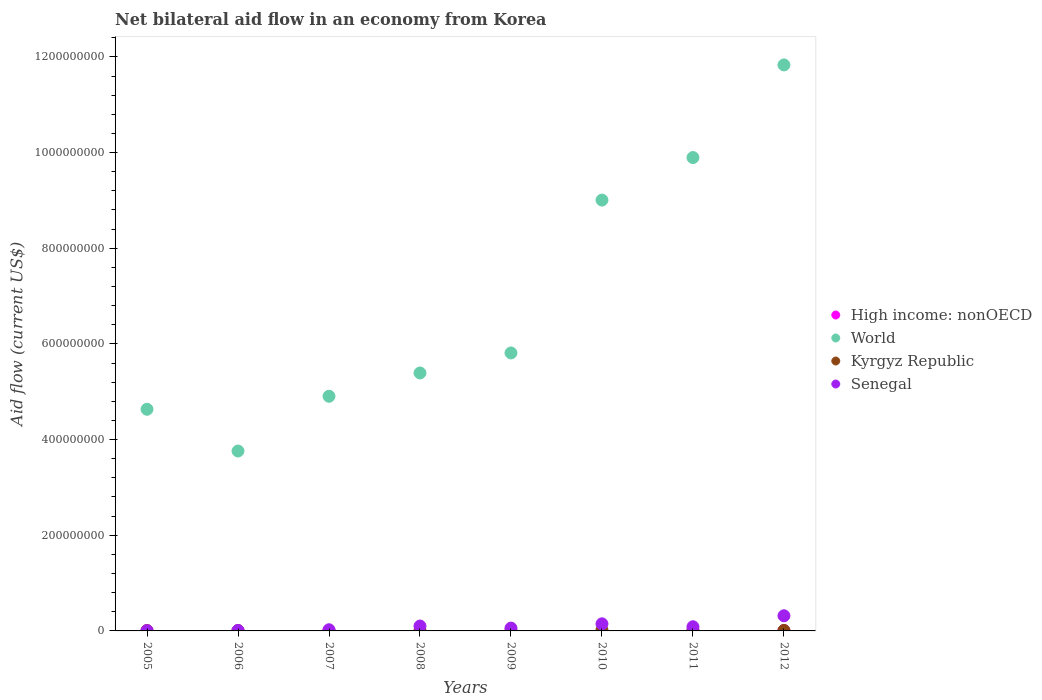Is the number of dotlines equal to the number of legend labels?
Keep it short and to the point. No. What is the net bilateral aid flow in Senegal in 2010?
Provide a short and direct response. 1.48e+07. Across all years, what is the maximum net bilateral aid flow in Senegal?
Give a very brief answer. 3.17e+07. In which year was the net bilateral aid flow in Senegal maximum?
Offer a terse response. 2012. What is the total net bilateral aid flow in Senegal in the graph?
Offer a terse response. 7.50e+07. What is the difference between the net bilateral aid flow in Senegal in 2005 and that in 2009?
Offer a terse response. -5.61e+06. What is the difference between the net bilateral aid flow in Kyrgyz Republic in 2010 and the net bilateral aid flow in High income: nonOECD in 2008?
Keep it short and to the point. 1.83e+06. What is the average net bilateral aid flow in High income: nonOECD per year?
Give a very brief answer. 4.24e+05. In the year 2012, what is the difference between the net bilateral aid flow in Senegal and net bilateral aid flow in Kyrgyz Republic?
Provide a succinct answer. 3.07e+07. What is the ratio of the net bilateral aid flow in Kyrgyz Republic in 2010 to that in 2011?
Offer a terse response. 1.51. Is the difference between the net bilateral aid flow in Senegal in 2010 and 2012 greater than the difference between the net bilateral aid flow in Kyrgyz Republic in 2010 and 2012?
Keep it short and to the point. No. What is the difference between the highest and the second highest net bilateral aid flow in World?
Make the answer very short. 1.94e+08. What is the difference between the highest and the lowest net bilateral aid flow in Senegal?
Make the answer very short. 3.14e+07. Is the sum of the net bilateral aid flow in Senegal in 2006 and 2011 greater than the maximum net bilateral aid flow in High income: nonOECD across all years?
Offer a terse response. Yes. Is the net bilateral aid flow in High income: nonOECD strictly greater than the net bilateral aid flow in Kyrgyz Republic over the years?
Make the answer very short. No. Is the net bilateral aid flow in World strictly less than the net bilateral aid flow in Senegal over the years?
Your response must be concise. No. What is the difference between two consecutive major ticks on the Y-axis?
Make the answer very short. 2.00e+08. Where does the legend appear in the graph?
Your answer should be compact. Center right. How are the legend labels stacked?
Provide a short and direct response. Vertical. What is the title of the graph?
Your answer should be compact. Net bilateral aid flow in an economy from Korea. What is the Aid flow (current US$) of High income: nonOECD in 2005?
Provide a short and direct response. 8.20e+05. What is the Aid flow (current US$) of World in 2005?
Provide a short and direct response. 4.63e+08. What is the Aid flow (current US$) of World in 2006?
Offer a very short reply. 3.76e+08. What is the Aid flow (current US$) of Senegal in 2006?
Give a very brief answer. 8.50e+05. What is the Aid flow (current US$) of High income: nonOECD in 2007?
Your answer should be very brief. 7.70e+05. What is the Aid flow (current US$) in World in 2007?
Provide a succinct answer. 4.91e+08. What is the Aid flow (current US$) of Kyrgyz Republic in 2007?
Your response must be concise. 1.50e+05. What is the Aid flow (current US$) of Senegal in 2007?
Your response must be concise. 2.43e+06. What is the Aid flow (current US$) in High income: nonOECD in 2008?
Give a very brief answer. 0. What is the Aid flow (current US$) in World in 2008?
Offer a terse response. 5.39e+08. What is the Aid flow (current US$) in Kyrgyz Republic in 2008?
Give a very brief answer. 7.10e+05. What is the Aid flow (current US$) in Senegal in 2008?
Give a very brief answer. 1.02e+07. What is the Aid flow (current US$) in World in 2009?
Provide a short and direct response. 5.81e+08. What is the Aid flow (current US$) of Kyrgyz Republic in 2009?
Offer a very short reply. 7.20e+05. What is the Aid flow (current US$) in Senegal in 2009?
Your response must be concise. 5.92e+06. What is the Aid flow (current US$) of World in 2010?
Offer a very short reply. 9.01e+08. What is the Aid flow (current US$) of Kyrgyz Republic in 2010?
Offer a terse response. 1.83e+06. What is the Aid flow (current US$) of Senegal in 2010?
Provide a short and direct response. 1.48e+07. What is the Aid flow (current US$) of High income: nonOECD in 2011?
Give a very brief answer. 6.00e+05. What is the Aid flow (current US$) of World in 2011?
Offer a very short reply. 9.90e+08. What is the Aid flow (current US$) of Kyrgyz Republic in 2011?
Offer a very short reply. 1.21e+06. What is the Aid flow (current US$) of Senegal in 2011?
Your answer should be very brief. 8.71e+06. What is the Aid flow (current US$) of High income: nonOECD in 2012?
Offer a very short reply. 7.00e+05. What is the Aid flow (current US$) of World in 2012?
Provide a succinct answer. 1.18e+09. What is the Aid flow (current US$) of Senegal in 2012?
Provide a succinct answer. 3.17e+07. Across all years, what is the maximum Aid flow (current US$) in High income: nonOECD?
Give a very brief answer. 8.20e+05. Across all years, what is the maximum Aid flow (current US$) in World?
Provide a succinct answer. 1.18e+09. Across all years, what is the maximum Aid flow (current US$) of Kyrgyz Republic?
Offer a terse response. 1.83e+06. Across all years, what is the maximum Aid flow (current US$) in Senegal?
Offer a very short reply. 3.17e+07. Across all years, what is the minimum Aid flow (current US$) of High income: nonOECD?
Provide a short and direct response. 0. Across all years, what is the minimum Aid flow (current US$) in World?
Your response must be concise. 3.76e+08. Across all years, what is the minimum Aid flow (current US$) of Kyrgyz Republic?
Your answer should be very brief. 1.50e+05. What is the total Aid flow (current US$) in High income: nonOECD in the graph?
Offer a very short reply. 3.39e+06. What is the total Aid flow (current US$) in World in the graph?
Offer a terse response. 5.52e+09. What is the total Aid flow (current US$) in Kyrgyz Republic in the graph?
Your answer should be compact. 6.65e+06. What is the total Aid flow (current US$) in Senegal in the graph?
Provide a short and direct response. 7.50e+07. What is the difference between the Aid flow (current US$) in World in 2005 and that in 2006?
Give a very brief answer. 8.73e+07. What is the difference between the Aid flow (current US$) of Senegal in 2005 and that in 2006?
Your answer should be compact. -5.40e+05. What is the difference between the Aid flow (current US$) of World in 2005 and that in 2007?
Offer a terse response. -2.72e+07. What is the difference between the Aid flow (current US$) in Senegal in 2005 and that in 2007?
Keep it short and to the point. -2.12e+06. What is the difference between the Aid flow (current US$) of World in 2005 and that in 2008?
Your response must be concise. -7.59e+07. What is the difference between the Aid flow (current US$) in Senegal in 2005 and that in 2008?
Give a very brief answer. -9.94e+06. What is the difference between the Aid flow (current US$) in World in 2005 and that in 2009?
Make the answer very short. -1.18e+08. What is the difference between the Aid flow (current US$) of Senegal in 2005 and that in 2009?
Your response must be concise. -5.61e+06. What is the difference between the Aid flow (current US$) of World in 2005 and that in 2010?
Make the answer very short. -4.37e+08. What is the difference between the Aid flow (current US$) in Kyrgyz Republic in 2005 and that in 2010?
Provide a short and direct response. -1.41e+06. What is the difference between the Aid flow (current US$) in Senegal in 2005 and that in 2010?
Keep it short and to the point. -1.45e+07. What is the difference between the Aid flow (current US$) of High income: nonOECD in 2005 and that in 2011?
Your answer should be compact. 2.20e+05. What is the difference between the Aid flow (current US$) of World in 2005 and that in 2011?
Provide a succinct answer. -5.26e+08. What is the difference between the Aid flow (current US$) of Kyrgyz Republic in 2005 and that in 2011?
Give a very brief answer. -7.90e+05. What is the difference between the Aid flow (current US$) of Senegal in 2005 and that in 2011?
Your answer should be compact. -8.40e+06. What is the difference between the Aid flow (current US$) in High income: nonOECD in 2005 and that in 2012?
Your answer should be compact. 1.20e+05. What is the difference between the Aid flow (current US$) in World in 2005 and that in 2012?
Provide a short and direct response. -7.20e+08. What is the difference between the Aid flow (current US$) in Kyrgyz Republic in 2005 and that in 2012?
Offer a very short reply. -5.80e+05. What is the difference between the Aid flow (current US$) in Senegal in 2005 and that in 2012?
Your answer should be very brief. -3.14e+07. What is the difference between the Aid flow (current US$) in World in 2006 and that in 2007?
Make the answer very short. -1.14e+08. What is the difference between the Aid flow (current US$) in Kyrgyz Republic in 2006 and that in 2007?
Your response must be concise. 4.60e+05. What is the difference between the Aid flow (current US$) in Senegal in 2006 and that in 2007?
Your answer should be compact. -1.58e+06. What is the difference between the Aid flow (current US$) of World in 2006 and that in 2008?
Your answer should be very brief. -1.63e+08. What is the difference between the Aid flow (current US$) of Senegal in 2006 and that in 2008?
Ensure brevity in your answer.  -9.40e+06. What is the difference between the Aid flow (current US$) of World in 2006 and that in 2009?
Your answer should be compact. -2.05e+08. What is the difference between the Aid flow (current US$) of Kyrgyz Republic in 2006 and that in 2009?
Offer a terse response. -1.10e+05. What is the difference between the Aid flow (current US$) in Senegal in 2006 and that in 2009?
Your answer should be compact. -5.07e+06. What is the difference between the Aid flow (current US$) in World in 2006 and that in 2010?
Your response must be concise. -5.25e+08. What is the difference between the Aid flow (current US$) in Kyrgyz Republic in 2006 and that in 2010?
Your response must be concise. -1.22e+06. What is the difference between the Aid flow (current US$) in Senegal in 2006 and that in 2010?
Provide a succinct answer. -1.40e+07. What is the difference between the Aid flow (current US$) of World in 2006 and that in 2011?
Offer a terse response. -6.13e+08. What is the difference between the Aid flow (current US$) in Kyrgyz Republic in 2006 and that in 2011?
Offer a terse response. -6.00e+05. What is the difference between the Aid flow (current US$) in Senegal in 2006 and that in 2011?
Offer a terse response. -7.86e+06. What is the difference between the Aid flow (current US$) in World in 2006 and that in 2012?
Your answer should be very brief. -8.07e+08. What is the difference between the Aid flow (current US$) in Kyrgyz Republic in 2006 and that in 2012?
Offer a very short reply. -3.90e+05. What is the difference between the Aid flow (current US$) of Senegal in 2006 and that in 2012?
Provide a short and direct response. -3.08e+07. What is the difference between the Aid flow (current US$) of World in 2007 and that in 2008?
Make the answer very short. -4.87e+07. What is the difference between the Aid flow (current US$) in Kyrgyz Republic in 2007 and that in 2008?
Ensure brevity in your answer.  -5.60e+05. What is the difference between the Aid flow (current US$) in Senegal in 2007 and that in 2008?
Your answer should be very brief. -7.82e+06. What is the difference between the Aid flow (current US$) of World in 2007 and that in 2009?
Your answer should be compact. -9.06e+07. What is the difference between the Aid flow (current US$) in Kyrgyz Republic in 2007 and that in 2009?
Offer a very short reply. -5.70e+05. What is the difference between the Aid flow (current US$) of Senegal in 2007 and that in 2009?
Your response must be concise. -3.49e+06. What is the difference between the Aid flow (current US$) of World in 2007 and that in 2010?
Offer a very short reply. -4.10e+08. What is the difference between the Aid flow (current US$) of Kyrgyz Republic in 2007 and that in 2010?
Offer a terse response. -1.68e+06. What is the difference between the Aid flow (current US$) of Senegal in 2007 and that in 2010?
Keep it short and to the point. -1.24e+07. What is the difference between the Aid flow (current US$) in High income: nonOECD in 2007 and that in 2011?
Make the answer very short. 1.70e+05. What is the difference between the Aid flow (current US$) of World in 2007 and that in 2011?
Keep it short and to the point. -4.99e+08. What is the difference between the Aid flow (current US$) of Kyrgyz Republic in 2007 and that in 2011?
Keep it short and to the point. -1.06e+06. What is the difference between the Aid flow (current US$) of Senegal in 2007 and that in 2011?
Make the answer very short. -6.28e+06. What is the difference between the Aid flow (current US$) of World in 2007 and that in 2012?
Offer a very short reply. -6.93e+08. What is the difference between the Aid flow (current US$) of Kyrgyz Republic in 2007 and that in 2012?
Your answer should be compact. -8.50e+05. What is the difference between the Aid flow (current US$) in Senegal in 2007 and that in 2012?
Offer a very short reply. -2.92e+07. What is the difference between the Aid flow (current US$) of World in 2008 and that in 2009?
Provide a succinct answer. -4.19e+07. What is the difference between the Aid flow (current US$) in Senegal in 2008 and that in 2009?
Keep it short and to the point. 4.33e+06. What is the difference between the Aid flow (current US$) in World in 2008 and that in 2010?
Provide a succinct answer. -3.61e+08. What is the difference between the Aid flow (current US$) in Kyrgyz Republic in 2008 and that in 2010?
Your answer should be very brief. -1.12e+06. What is the difference between the Aid flow (current US$) in Senegal in 2008 and that in 2010?
Provide a short and direct response. -4.60e+06. What is the difference between the Aid flow (current US$) of World in 2008 and that in 2011?
Your answer should be compact. -4.50e+08. What is the difference between the Aid flow (current US$) of Kyrgyz Republic in 2008 and that in 2011?
Your response must be concise. -5.00e+05. What is the difference between the Aid flow (current US$) in Senegal in 2008 and that in 2011?
Give a very brief answer. 1.54e+06. What is the difference between the Aid flow (current US$) in World in 2008 and that in 2012?
Your answer should be compact. -6.44e+08. What is the difference between the Aid flow (current US$) of Senegal in 2008 and that in 2012?
Your response must be concise. -2.14e+07. What is the difference between the Aid flow (current US$) in World in 2009 and that in 2010?
Give a very brief answer. -3.20e+08. What is the difference between the Aid flow (current US$) in Kyrgyz Republic in 2009 and that in 2010?
Offer a very short reply. -1.11e+06. What is the difference between the Aid flow (current US$) in Senegal in 2009 and that in 2010?
Offer a terse response. -8.93e+06. What is the difference between the Aid flow (current US$) in World in 2009 and that in 2011?
Keep it short and to the point. -4.08e+08. What is the difference between the Aid flow (current US$) in Kyrgyz Republic in 2009 and that in 2011?
Provide a succinct answer. -4.90e+05. What is the difference between the Aid flow (current US$) of Senegal in 2009 and that in 2011?
Offer a very short reply. -2.79e+06. What is the difference between the Aid flow (current US$) in World in 2009 and that in 2012?
Your response must be concise. -6.02e+08. What is the difference between the Aid flow (current US$) in Kyrgyz Republic in 2009 and that in 2012?
Your response must be concise. -2.80e+05. What is the difference between the Aid flow (current US$) in Senegal in 2009 and that in 2012?
Your answer should be very brief. -2.58e+07. What is the difference between the Aid flow (current US$) in World in 2010 and that in 2011?
Make the answer very short. -8.89e+07. What is the difference between the Aid flow (current US$) in Kyrgyz Republic in 2010 and that in 2011?
Keep it short and to the point. 6.20e+05. What is the difference between the Aid flow (current US$) of Senegal in 2010 and that in 2011?
Your answer should be compact. 6.14e+06. What is the difference between the Aid flow (current US$) in World in 2010 and that in 2012?
Keep it short and to the point. -2.83e+08. What is the difference between the Aid flow (current US$) of Kyrgyz Republic in 2010 and that in 2012?
Keep it short and to the point. 8.30e+05. What is the difference between the Aid flow (current US$) of Senegal in 2010 and that in 2012?
Ensure brevity in your answer.  -1.68e+07. What is the difference between the Aid flow (current US$) of World in 2011 and that in 2012?
Provide a succinct answer. -1.94e+08. What is the difference between the Aid flow (current US$) of Senegal in 2011 and that in 2012?
Your answer should be compact. -2.30e+07. What is the difference between the Aid flow (current US$) in High income: nonOECD in 2005 and the Aid flow (current US$) in World in 2006?
Provide a short and direct response. -3.75e+08. What is the difference between the Aid flow (current US$) of High income: nonOECD in 2005 and the Aid flow (current US$) of Senegal in 2006?
Your answer should be very brief. -3.00e+04. What is the difference between the Aid flow (current US$) of World in 2005 and the Aid flow (current US$) of Kyrgyz Republic in 2006?
Provide a succinct answer. 4.63e+08. What is the difference between the Aid flow (current US$) in World in 2005 and the Aid flow (current US$) in Senegal in 2006?
Offer a very short reply. 4.62e+08. What is the difference between the Aid flow (current US$) of Kyrgyz Republic in 2005 and the Aid flow (current US$) of Senegal in 2006?
Provide a succinct answer. -4.30e+05. What is the difference between the Aid flow (current US$) of High income: nonOECD in 2005 and the Aid flow (current US$) of World in 2007?
Keep it short and to the point. -4.90e+08. What is the difference between the Aid flow (current US$) in High income: nonOECD in 2005 and the Aid flow (current US$) in Kyrgyz Republic in 2007?
Provide a short and direct response. 6.70e+05. What is the difference between the Aid flow (current US$) of High income: nonOECD in 2005 and the Aid flow (current US$) of Senegal in 2007?
Keep it short and to the point. -1.61e+06. What is the difference between the Aid flow (current US$) of World in 2005 and the Aid flow (current US$) of Kyrgyz Republic in 2007?
Your response must be concise. 4.63e+08. What is the difference between the Aid flow (current US$) in World in 2005 and the Aid flow (current US$) in Senegal in 2007?
Make the answer very short. 4.61e+08. What is the difference between the Aid flow (current US$) of Kyrgyz Republic in 2005 and the Aid flow (current US$) of Senegal in 2007?
Your response must be concise. -2.01e+06. What is the difference between the Aid flow (current US$) of High income: nonOECD in 2005 and the Aid flow (current US$) of World in 2008?
Your answer should be very brief. -5.38e+08. What is the difference between the Aid flow (current US$) in High income: nonOECD in 2005 and the Aid flow (current US$) in Kyrgyz Republic in 2008?
Your answer should be compact. 1.10e+05. What is the difference between the Aid flow (current US$) of High income: nonOECD in 2005 and the Aid flow (current US$) of Senegal in 2008?
Your response must be concise. -9.43e+06. What is the difference between the Aid flow (current US$) of World in 2005 and the Aid flow (current US$) of Kyrgyz Republic in 2008?
Your answer should be compact. 4.63e+08. What is the difference between the Aid flow (current US$) in World in 2005 and the Aid flow (current US$) in Senegal in 2008?
Your answer should be compact. 4.53e+08. What is the difference between the Aid flow (current US$) of Kyrgyz Republic in 2005 and the Aid flow (current US$) of Senegal in 2008?
Your response must be concise. -9.83e+06. What is the difference between the Aid flow (current US$) in High income: nonOECD in 2005 and the Aid flow (current US$) in World in 2009?
Make the answer very short. -5.80e+08. What is the difference between the Aid flow (current US$) of High income: nonOECD in 2005 and the Aid flow (current US$) of Kyrgyz Republic in 2009?
Give a very brief answer. 1.00e+05. What is the difference between the Aid flow (current US$) in High income: nonOECD in 2005 and the Aid flow (current US$) in Senegal in 2009?
Keep it short and to the point. -5.10e+06. What is the difference between the Aid flow (current US$) in World in 2005 and the Aid flow (current US$) in Kyrgyz Republic in 2009?
Your answer should be very brief. 4.63e+08. What is the difference between the Aid flow (current US$) in World in 2005 and the Aid flow (current US$) in Senegal in 2009?
Your response must be concise. 4.57e+08. What is the difference between the Aid flow (current US$) in Kyrgyz Republic in 2005 and the Aid flow (current US$) in Senegal in 2009?
Your answer should be very brief. -5.50e+06. What is the difference between the Aid flow (current US$) of High income: nonOECD in 2005 and the Aid flow (current US$) of World in 2010?
Your response must be concise. -9.00e+08. What is the difference between the Aid flow (current US$) of High income: nonOECD in 2005 and the Aid flow (current US$) of Kyrgyz Republic in 2010?
Make the answer very short. -1.01e+06. What is the difference between the Aid flow (current US$) of High income: nonOECD in 2005 and the Aid flow (current US$) of Senegal in 2010?
Make the answer very short. -1.40e+07. What is the difference between the Aid flow (current US$) in World in 2005 and the Aid flow (current US$) in Kyrgyz Republic in 2010?
Your response must be concise. 4.62e+08. What is the difference between the Aid flow (current US$) in World in 2005 and the Aid flow (current US$) in Senegal in 2010?
Provide a short and direct response. 4.48e+08. What is the difference between the Aid flow (current US$) in Kyrgyz Republic in 2005 and the Aid flow (current US$) in Senegal in 2010?
Provide a succinct answer. -1.44e+07. What is the difference between the Aid flow (current US$) in High income: nonOECD in 2005 and the Aid flow (current US$) in World in 2011?
Your answer should be compact. -9.89e+08. What is the difference between the Aid flow (current US$) of High income: nonOECD in 2005 and the Aid flow (current US$) of Kyrgyz Republic in 2011?
Your answer should be very brief. -3.90e+05. What is the difference between the Aid flow (current US$) in High income: nonOECD in 2005 and the Aid flow (current US$) in Senegal in 2011?
Your answer should be very brief. -7.89e+06. What is the difference between the Aid flow (current US$) in World in 2005 and the Aid flow (current US$) in Kyrgyz Republic in 2011?
Offer a terse response. 4.62e+08. What is the difference between the Aid flow (current US$) of World in 2005 and the Aid flow (current US$) of Senegal in 2011?
Offer a terse response. 4.55e+08. What is the difference between the Aid flow (current US$) in Kyrgyz Republic in 2005 and the Aid flow (current US$) in Senegal in 2011?
Provide a short and direct response. -8.29e+06. What is the difference between the Aid flow (current US$) of High income: nonOECD in 2005 and the Aid flow (current US$) of World in 2012?
Your answer should be compact. -1.18e+09. What is the difference between the Aid flow (current US$) in High income: nonOECD in 2005 and the Aid flow (current US$) in Senegal in 2012?
Keep it short and to the point. -3.09e+07. What is the difference between the Aid flow (current US$) of World in 2005 and the Aid flow (current US$) of Kyrgyz Republic in 2012?
Offer a very short reply. 4.62e+08. What is the difference between the Aid flow (current US$) of World in 2005 and the Aid flow (current US$) of Senegal in 2012?
Your answer should be very brief. 4.32e+08. What is the difference between the Aid flow (current US$) of Kyrgyz Republic in 2005 and the Aid flow (current US$) of Senegal in 2012?
Keep it short and to the point. -3.13e+07. What is the difference between the Aid flow (current US$) of High income: nonOECD in 2006 and the Aid flow (current US$) of World in 2007?
Make the answer very short. -4.90e+08. What is the difference between the Aid flow (current US$) in High income: nonOECD in 2006 and the Aid flow (current US$) in Senegal in 2007?
Make the answer very short. -1.93e+06. What is the difference between the Aid flow (current US$) of World in 2006 and the Aid flow (current US$) of Kyrgyz Republic in 2007?
Make the answer very short. 3.76e+08. What is the difference between the Aid flow (current US$) of World in 2006 and the Aid flow (current US$) of Senegal in 2007?
Ensure brevity in your answer.  3.74e+08. What is the difference between the Aid flow (current US$) in Kyrgyz Republic in 2006 and the Aid flow (current US$) in Senegal in 2007?
Offer a very short reply. -1.82e+06. What is the difference between the Aid flow (current US$) in High income: nonOECD in 2006 and the Aid flow (current US$) in World in 2008?
Give a very brief answer. -5.39e+08. What is the difference between the Aid flow (current US$) of High income: nonOECD in 2006 and the Aid flow (current US$) of Kyrgyz Republic in 2008?
Make the answer very short. -2.10e+05. What is the difference between the Aid flow (current US$) in High income: nonOECD in 2006 and the Aid flow (current US$) in Senegal in 2008?
Give a very brief answer. -9.75e+06. What is the difference between the Aid flow (current US$) of World in 2006 and the Aid flow (current US$) of Kyrgyz Republic in 2008?
Offer a very short reply. 3.75e+08. What is the difference between the Aid flow (current US$) of World in 2006 and the Aid flow (current US$) of Senegal in 2008?
Provide a succinct answer. 3.66e+08. What is the difference between the Aid flow (current US$) of Kyrgyz Republic in 2006 and the Aid flow (current US$) of Senegal in 2008?
Make the answer very short. -9.64e+06. What is the difference between the Aid flow (current US$) of High income: nonOECD in 2006 and the Aid flow (current US$) of World in 2009?
Provide a succinct answer. -5.81e+08. What is the difference between the Aid flow (current US$) in High income: nonOECD in 2006 and the Aid flow (current US$) in Kyrgyz Republic in 2009?
Offer a very short reply. -2.20e+05. What is the difference between the Aid flow (current US$) of High income: nonOECD in 2006 and the Aid flow (current US$) of Senegal in 2009?
Your response must be concise. -5.42e+06. What is the difference between the Aid flow (current US$) in World in 2006 and the Aid flow (current US$) in Kyrgyz Republic in 2009?
Provide a short and direct response. 3.75e+08. What is the difference between the Aid flow (current US$) of World in 2006 and the Aid flow (current US$) of Senegal in 2009?
Make the answer very short. 3.70e+08. What is the difference between the Aid flow (current US$) in Kyrgyz Republic in 2006 and the Aid flow (current US$) in Senegal in 2009?
Ensure brevity in your answer.  -5.31e+06. What is the difference between the Aid flow (current US$) in High income: nonOECD in 2006 and the Aid flow (current US$) in World in 2010?
Make the answer very short. -9.00e+08. What is the difference between the Aid flow (current US$) in High income: nonOECD in 2006 and the Aid flow (current US$) in Kyrgyz Republic in 2010?
Your response must be concise. -1.33e+06. What is the difference between the Aid flow (current US$) in High income: nonOECD in 2006 and the Aid flow (current US$) in Senegal in 2010?
Make the answer very short. -1.44e+07. What is the difference between the Aid flow (current US$) of World in 2006 and the Aid flow (current US$) of Kyrgyz Republic in 2010?
Your answer should be compact. 3.74e+08. What is the difference between the Aid flow (current US$) in World in 2006 and the Aid flow (current US$) in Senegal in 2010?
Your answer should be compact. 3.61e+08. What is the difference between the Aid flow (current US$) of Kyrgyz Republic in 2006 and the Aid flow (current US$) of Senegal in 2010?
Ensure brevity in your answer.  -1.42e+07. What is the difference between the Aid flow (current US$) in High income: nonOECD in 2006 and the Aid flow (current US$) in World in 2011?
Your response must be concise. -9.89e+08. What is the difference between the Aid flow (current US$) of High income: nonOECD in 2006 and the Aid flow (current US$) of Kyrgyz Republic in 2011?
Your response must be concise. -7.10e+05. What is the difference between the Aid flow (current US$) in High income: nonOECD in 2006 and the Aid flow (current US$) in Senegal in 2011?
Keep it short and to the point. -8.21e+06. What is the difference between the Aid flow (current US$) in World in 2006 and the Aid flow (current US$) in Kyrgyz Republic in 2011?
Make the answer very short. 3.75e+08. What is the difference between the Aid flow (current US$) in World in 2006 and the Aid flow (current US$) in Senegal in 2011?
Keep it short and to the point. 3.67e+08. What is the difference between the Aid flow (current US$) of Kyrgyz Republic in 2006 and the Aid flow (current US$) of Senegal in 2011?
Make the answer very short. -8.10e+06. What is the difference between the Aid flow (current US$) in High income: nonOECD in 2006 and the Aid flow (current US$) in World in 2012?
Ensure brevity in your answer.  -1.18e+09. What is the difference between the Aid flow (current US$) in High income: nonOECD in 2006 and the Aid flow (current US$) in Kyrgyz Republic in 2012?
Keep it short and to the point. -5.00e+05. What is the difference between the Aid flow (current US$) in High income: nonOECD in 2006 and the Aid flow (current US$) in Senegal in 2012?
Offer a terse response. -3.12e+07. What is the difference between the Aid flow (current US$) of World in 2006 and the Aid flow (current US$) of Kyrgyz Republic in 2012?
Give a very brief answer. 3.75e+08. What is the difference between the Aid flow (current US$) of World in 2006 and the Aid flow (current US$) of Senegal in 2012?
Provide a succinct answer. 3.44e+08. What is the difference between the Aid flow (current US$) in Kyrgyz Republic in 2006 and the Aid flow (current US$) in Senegal in 2012?
Provide a short and direct response. -3.11e+07. What is the difference between the Aid flow (current US$) of High income: nonOECD in 2007 and the Aid flow (current US$) of World in 2008?
Your response must be concise. -5.38e+08. What is the difference between the Aid flow (current US$) in High income: nonOECD in 2007 and the Aid flow (current US$) in Kyrgyz Republic in 2008?
Provide a succinct answer. 6.00e+04. What is the difference between the Aid flow (current US$) in High income: nonOECD in 2007 and the Aid flow (current US$) in Senegal in 2008?
Ensure brevity in your answer.  -9.48e+06. What is the difference between the Aid flow (current US$) in World in 2007 and the Aid flow (current US$) in Kyrgyz Republic in 2008?
Your answer should be very brief. 4.90e+08. What is the difference between the Aid flow (current US$) of World in 2007 and the Aid flow (current US$) of Senegal in 2008?
Offer a terse response. 4.80e+08. What is the difference between the Aid flow (current US$) of Kyrgyz Republic in 2007 and the Aid flow (current US$) of Senegal in 2008?
Offer a terse response. -1.01e+07. What is the difference between the Aid flow (current US$) of High income: nonOECD in 2007 and the Aid flow (current US$) of World in 2009?
Your answer should be compact. -5.80e+08. What is the difference between the Aid flow (current US$) of High income: nonOECD in 2007 and the Aid flow (current US$) of Kyrgyz Republic in 2009?
Make the answer very short. 5.00e+04. What is the difference between the Aid flow (current US$) of High income: nonOECD in 2007 and the Aid flow (current US$) of Senegal in 2009?
Offer a very short reply. -5.15e+06. What is the difference between the Aid flow (current US$) in World in 2007 and the Aid flow (current US$) in Kyrgyz Republic in 2009?
Keep it short and to the point. 4.90e+08. What is the difference between the Aid flow (current US$) of World in 2007 and the Aid flow (current US$) of Senegal in 2009?
Ensure brevity in your answer.  4.85e+08. What is the difference between the Aid flow (current US$) of Kyrgyz Republic in 2007 and the Aid flow (current US$) of Senegal in 2009?
Your response must be concise. -5.77e+06. What is the difference between the Aid flow (current US$) of High income: nonOECD in 2007 and the Aid flow (current US$) of World in 2010?
Your answer should be compact. -9.00e+08. What is the difference between the Aid flow (current US$) in High income: nonOECD in 2007 and the Aid flow (current US$) in Kyrgyz Republic in 2010?
Provide a succinct answer. -1.06e+06. What is the difference between the Aid flow (current US$) in High income: nonOECD in 2007 and the Aid flow (current US$) in Senegal in 2010?
Keep it short and to the point. -1.41e+07. What is the difference between the Aid flow (current US$) in World in 2007 and the Aid flow (current US$) in Kyrgyz Republic in 2010?
Your response must be concise. 4.89e+08. What is the difference between the Aid flow (current US$) of World in 2007 and the Aid flow (current US$) of Senegal in 2010?
Provide a succinct answer. 4.76e+08. What is the difference between the Aid flow (current US$) of Kyrgyz Republic in 2007 and the Aid flow (current US$) of Senegal in 2010?
Offer a terse response. -1.47e+07. What is the difference between the Aid flow (current US$) in High income: nonOECD in 2007 and the Aid flow (current US$) in World in 2011?
Your response must be concise. -9.89e+08. What is the difference between the Aid flow (current US$) in High income: nonOECD in 2007 and the Aid flow (current US$) in Kyrgyz Republic in 2011?
Ensure brevity in your answer.  -4.40e+05. What is the difference between the Aid flow (current US$) in High income: nonOECD in 2007 and the Aid flow (current US$) in Senegal in 2011?
Your answer should be very brief. -7.94e+06. What is the difference between the Aid flow (current US$) in World in 2007 and the Aid flow (current US$) in Kyrgyz Republic in 2011?
Keep it short and to the point. 4.89e+08. What is the difference between the Aid flow (current US$) of World in 2007 and the Aid flow (current US$) of Senegal in 2011?
Your answer should be compact. 4.82e+08. What is the difference between the Aid flow (current US$) in Kyrgyz Republic in 2007 and the Aid flow (current US$) in Senegal in 2011?
Give a very brief answer. -8.56e+06. What is the difference between the Aid flow (current US$) of High income: nonOECD in 2007 and the Aid flow (current US$) of World in 2012?
Offer a very short reply. -1.18e+09. What is the difference between the Aid flow (current US$) of High income: nonOECD in 2007 and the Aid flow (current US$) of Kyrgyz Republic in 2012?
Your response must be concise. -2.30e+05. What is the difference between the Aid flow (current US$) in High income: nonOECD in 2007 and the Aid flow (current US$) in Senegal in 2012?
Provide a short and direct response. -3.09e+07. What is the difference between the Aid flow (current US$) of World in 2007 and the Aid flow (current US$) of Kyrgyz Republic in 2012?
Make the answer very short. 4.90e+08. What is the difference between the Aid flow (current US$) in World in 2007 and the Aid flow (current US$) in Senegal in 2012?
Your response must be concise. 4.59e+08. What is the difference between the Aid flow (current US$) of Kyrgyz Republic in 2007 and the Aid flow (current US$) of Senegal in 2012?
Offer a terse response. -3.15e+07. What is the difference between the Aid flow (current US$) in World in 2008 and the Aid flow (current US$) in Kyrgyz Republic in 2009?
Your answer should be compact. 5.38e+08. What is the difference between the Aid flow (current US$) in World in 2008 and the Aid flow (current US$) in Senegal in 2009?
Keep it short and to the point. 5.33e+08. What is the difference between the Aid flow (current US$) of Kyrgyz Republic in 2008 and the Aid flow (current US$) of Senegal in 2009?
Keep it short and to the point. -5.21e+06. What is the difference between the Aid flow (current US$) of World in 2008 and the Aid flow (current US$) of Kyrgyz Republic in 2010?
Offer a very short reply. 5.37e+08. What is the difference between the Aid flow (current US$) of World in 2008 and the Aid flow (current US$) of Senegal in 2010?
Provide a succinct answer. 5.24e+08. What is the difference between the Aid flow (current US$) in Kyrgyz Republic in 2008 and the Aid flow (current US$) in Senegal in 2010?
Provide a short and direct response. -1.41e+07. What is the difference between the Aid flow (current US$) in World in 2008 and the Aid flow (current US$) in Kyrgyz Republic in 2011?
Your answer should be very brief. 5.38e+08. What is the difference between the Aid flow (current US$) of World in 2008 and the Aid flow (current US$) of Senegal in 2011?
Your answer should be very brief. 5.30e+08. What is the difference between the Aid flow (current US$) of Kyrgyz Republic in 2008 and the Aid flow (current US$) of Senegal in 2011?
Give a very brief answer. -8.00e+06. What is the difference between the Aid flow (current US$) in World in 2008 and the Aid flow (current US$) in Kyrgyz Republic in 2012?
Keep it short and to the point. 5.38e+08. What is the difference between the Aid flow (current US$) of World in 2008 and the Aid flow (current US$) of Senegal in 2012?
Offer a terse response. 5.08e+08. What is the difference between the Aid flow (current US$) in Kyrgyz Republic in 2008 and the Aid flow (current US$) in Senegal in 2012?
Ensure brevity in your answer.  -3.10e+07. What is the difference between the Aid flow (current US$) of World in 2009 and the Aid flow (current US$) of Kyrgyz Republic in 2010?
Your answer should be very brief. 5.79e+08. What is the difference between the Aid flow (current US$) in World in 2009 and the Aid flow (current US$) in Senegal in 2010?
Make the answer very short. 5.66e+08. What is the difference between the Aid flow (current US$) in Kyrgyz Republic in 2009 and the Aid flow (current US$) in Senegal in 2010?
Your answer should be compact. -1.41e+07. What is the difference between the Aid flow (current US$) of World in 2009 and the Aid flow (current US$) of Kyrgyz Republic in 2011?
Your response must be concise. 5.80e+08. What is the difference between the Aid flow (current US$) in World in 2009 and the Aid flow (current US$) in Senegal in 2011?
Your response must be concise. 5.72e+08. What is the difference between the Aid flow (current US$) of Kyrgyz Republic in 2009 and the Aid flow (current US$) of Senegal in 2011?
Make the answer very short. -7.99e+06. What is the difference between the Aid flow (current US$) of World in 2009 and the Aid flow (current US$) of Kyrgyz Republic in 2012?
Give a very brief answer. 5.80e+08. What is the difference between the Aid flow (current US$) of World in 2009 and the Aid flow (current US$) of Senegal in 2012?
Ensure brevity in your answer.  5.49e+08. What is the difference between the Aid flow (current US$) in Kyrgyz Republic in 2009 and the Aid flow (current US$) in Senegal in 2012?
Provide a short and direct response. -3.10e+07. What is the difference between the Aid flow (current US$) of World in 2010 and the Aid flow (current US$) of Kyrgyz Republic in 2011?
Your answer should be compact. 8.99e+08. What is the difference between the Aid flow (current US$) in World in 2010 and the Aid flow (current US$) in Senegal in 2011?
Provide a short and direct response. 8.92e+08. What is the difference between the Aid flow (current US$) of Kyrgyz Republic in 2010 and the Aid flow (current US$) of Senegal in 2011?
Ensure brevity in your answer.  -6.88e+06. What is the difference between the Aid flow (current US$) in World in 2010 and the Aid flow (current US$) in Kyrgyz Republic in 2012?
Keep it short and to the point. 9.00e+08. What is the difference between the Aid flow (current US$) of World in 2010 and the Aid flow (current US$) of Senegal in 2012?
Keep it short and to the point. 8.69e+08. What is the difference between the Aid flow (current US$) in Kyrgyz Republic in 2010 and the Aid flow (current US$) in Senegal in 2012?
Give a very brief answer. -2.98e+07. What is the difference between the Aid flow (current US$) in High income: nonOECD in 2011 and the Aid flow (current US$) in World in 2012?
Give a very brief answer. -1.18e+09. What is the difference between the Aid flow (current US$) in High income: nonOECD in 2011 and the Aid flow (current US$) in Kyrgyz Republic in 2012?
Provide a short and direct response. -4.00e+05. What is the difference between the Aid flow (current US$) of High income: nonOECD in 2011 and the Aid flow (current US$) of Senegal in 2012?
Your answer should be compact. -3.11e+07. What is the difference between the Aid flow (current US$) in World in 2011 and the Aid flow (current US$) in Kyrgyz Republic in 2012?
Your answer should be compact. 9.89e+08. What is the difference between the Aid flow (current US$) of World in 2011 and the Aid flow (current US$) of Senegal in 2012?
Provide a short and direct response. 9.58e+08. What is the difference between the Aid flow (current US$) of Kyrgyz Republic in 2011 and the Aid flow (current US$) of Senegal in 2012?
Provide a short and direct response. -3.05e+07. What is the average Aid flow (current US$) in High income: nonOECD per year?
Ensure brevity in your answer.  4.24e+05. What is the average Aid flow (current US$) of World per year?
Your response must be concise. 6.90e+08. What is the average Aid flow (current US$) in Kyrgyz Republic per year?
Keep it short and to the point. 8.31e+05. What is the average Aid flow (current US$) of Senegal per year?
Your response must be concise. 9.38e+06. In the year 2005, what is the difference between the Aid flow (current US$) of High income: nonOECD and Aid flow (current US$) of World?
Your answer should be very brief. -4.63e+08. In the year 2005, what is the difference between the Aid flow (current US$) in High income: nonOECD and Aid flow (current US$) in Senegal?
Ensure brevity in your answer.  5.10e+05. In the year 2005, what is the difference between the Aid flow (current US$) of World and Aid flow (current US$) of Kyrgyz Republic?
Your response must be concise. 4.63e+08. In the year 2005, what is the difference between the Aid flow (current US$) of World and Aid flow (current US$) of Senegal?
Your response must be concise. 4.63e+08. In the year 2006, what is the difference between the Aid flow (current US$) in High income: nonOECD and Aid flow (current US$) in World?
Your answer should be very brief. -3.76e+08. In the year 2006, what is the difference between the Aid flow (current US$) in High income: nonOECD and Aid flow (current US$) in Kyrgyz Republic?
Give a very brief answer. -1.10e+05. In the year 2006, what is the difference between the Aid flow (current US$) of High income: nonOECD and Aid flow (current US$) of Senegal?
Your answer should be very brief. -3.50e+05. In the year 2006, what is the difference between the Aid flow (current US$) in World and Aid flow (current US$) in Kyrgyz Republic?
Your answer should be very brief. 3.75e+08. In the year 2006, what is the difference between the Aid flow (current US$) of World and Aid flow (current US$) of Senegal?
Offer a very short reply. 3.75e+08. In the year 2007, what is the difference between the Aid flow (current US$) in High income: nonOECD and Aid flow (current US$) in World?
Offer a terse response. -4.90e+08. In the year 2007, what is the difference between the Aid flow (current US$) of High income: nonOECD and Aid flow (current US$) of Kyrgyz Republic?
Your answer should be very brief. 6.20e+05. In the year 2007, what is the difference between the Aid flow (current US$) of High income: nonOECD and Aid flow (current US$) of Senegal?
Your answer should be very brief. -1.66e+06. In the year 2007, what is the difference between the Aid flow (current US$) in World and Aid flow (current US$) in Kyrgyz Republic?
Give a very brief answer. 4.90e+08. In the year 2007, what is the difference between the Aid flow (current US$) of World and Aid flow (current US$) of Senegal?
Your answer should be compact. 4.88e+08. In the year 2007, what is the difference between the Aid flow (current US$) in Kyrgyz Republic and Aid flow (current US$) in Senegal?
Your response must be concise. -2.28e+06. In the year 2008, what is the difference between the Aid flow (current US$) in World and Aid flow (current US$) in Kyrgyz Republic?
Provide a succinct answer. 5.38e+08. In the year 2008, what is the difference between the Aid flow (current US$) of World and Aid flow (current US$) of Senegal?
Give a very brief answer. 5.29e+08. In the year 2008, what is the difference between the Aid flow (current US$) in Kyrgyz Republic and Aid flow (current US$) in Senegal?
Make the answer very short. -9.54e+06. In the year 2009, what is the difference between the Aid flow (current US$) in World and Aid flow (current US$) in Kyrgyz Republic?
Offer a terse response. 5.80e+08. In the year 2009, what is the difference between the Aid flow (current US$) of World and Aid flow (current US$) of Senegal?
Your answer should be very brief. 5.75e+08. In the year 2009, what is the difference between the Aid flow (current US$) of Kyrgyz Republic and Aid flow (current US$) of Senegal?
Provide a succinct answer. -5.20e+06. In the year 2010, what is the difference between the Aid flow (current US$) of World and Aid flow (current US$) of Kyrgyz Republic?
Offer a terse response. 8.99e+08. In the year 2010, what is the difference between the Aid flow (current US$) in World and Aid flow (current US$) in Senegal?
Keep it short and to the point. 8.86e+08. In the year 2010, what is the difference between the Aid flow (current US$) of Kyrgyz Republic and Aid flow (current US$) of Senegal?
Make the answer very short. -1.30e+07. In the year 2011, what is the difference between the Aid flow (current US$) in High income: nonOECD and Aid flow (current US$) in World?
Your answer should be very brief. -9.89e+08. In the year 2011, what is the difference between the Aid flow (current US$) in High income: nonOECD and Aid flow (current US$) in Kyrgyz Republic?
Make the answer very short. -6.10e+05. In the year 2011, what is the difference between the Aid flow (current US$) of High income: nonOECD and Aid flow (current US$) of Senegal?
Make the answer very short. -8.11e+06. In the year 2011, what is the difference between the Aid flow (current US$) of World and Aid flow (current US$) of Kyrgyz Republic?
Offer a very short reply. 9.88e+08. In the year 2011, what is the difference between the Aid flow (current US$) of World and Aid flow (current US$) of Senegal?
Your answer should be compact. 9.81e+08. In the year 2011, what is the difference between the Aid flow (current US$) of Kyrgyz Republic and Aid flow (current US$) of Senegal?
Your answer should be compact. -7.50e+06. In the year 2012, what is the difference between the Aid flow (current US$) of High income: nonOECD and Aid flow (current US$) of World?
Your response must be concise. -1.18e+09. In the year 2012, what is the difference between the Aid flow (current US$) of High income: nonOECD and Aid flow (current US$) of Kyrgyz Republic?
Your response must be concise. -3.00e+05. In the year 2012, what is the difference between the Aid flow (current US$) in High income: nonOECD and Aid flow (current US$) in Senegal?
Provide a short and direct response. -3.10e+07. In the year 2012, what is the difference between the Aid flow (current US$) in World and Aid flow (current US$) in Kyrgyz Republic?
Provide a short and direct response. 1.18e+09. In the year 2012, what is the difference between the Aid flow (current US$) in World and Aid flow (current US$) in Senegal?
Give a very brief answer. 1.15e+09. In the year 2012, what is the difference between the Aid flow (current US$) in Kyrgyz Republic and Aid flow (current US$) in Senegal?
Offer a terse response. -3.07e+07. What is the ratio of the Aid flow (current US$) in High income: nonOECD in 2005 to that in 2006?
Your answer should be compact. 1.64. What is the ratio of the Aid flow (current US$) in World in 2005 to that in 2006?
Offer a terse response. 1.23. What is the ratio of the Aid flow (current US$) in Kyrgyz Republic in 2005 to that in 2006?
Give a very brief answer. 0.69. What is the ratio of the Aid flow (current US$) in Senegal in 2005 to that in 2006?
Your response must be concise. 0.36. What is the ratio of the Aid flow (current US$) in High income: nonOECD in 2005 to that in 2007?
Offer a terse response. 1.06. What is the ratio of the Aid flow (current US$) in World in 2005 to that in 2007?
Provide a succinct answer. 0.94. What is the ratio of the Aid flow (current US$) in Senegal in 2005 to that in 2007?
Provide a short and direct response. 0.13. What is the ratio of the Aid flow (current US$) in World in 2005 to that in 2008?
Make the answer very short. 0.86. What is the ratio of the Aid flow (current US$) in Kyrgyz Republic in 2005 to that in 2008?
Your answer should be compact. 0.59. What is the ratio of the Aid flow (current US$) of Senegal in 2005 to that in 2008?
Offer a very short reply. 0.03. What is the ratio of the Aid flow (current US$) in World in 2005 to that in 2009?
Your answer should be compact. 0.8. What is the ratio of the Aid flow (current US$) in Kyrgyz Republic in 2005 to that in 2009?
Provide a short and direct response. 0.58. What is the ratio of the Aid flow (current US$) of Senegal in 2005 to that in 2009?
Your response must be concise. 0.05. What is the ratio of the Aid flow (current US$) in World in 2005 to that in 2010?
Ensure brevity in your answer.  0.51. What is the ratio of the Aid flow (current US$) in Kyrgyz Republic in 2005 to that in 2010?
Give a very brief answer. 0.23. What is the ratio of the Aid flow (current US$) of Senegal in 2005 to that in 2010?
Give a very brief answer. 0.02. What is the ratio of the Aid flow (current US$) in High income: nonOECD in 2005 to that in 2011?
Keep it short and to the point. 1.37. What is the ratio of the Aid flow (current US$) in World in 2005 to that in 2011?
Your response must be concise. 0.47. What is the ratio of the Aid flow (current US$) in Kyrgyz Republic in 2005 to that in 2011?
Offer a very short reply. 0.35. What is the ratio of the Aid flow (current US$) of Senegal in 2005 to that in 2011?
Ensure brevity in your answer.  0.04. What is the ratio of the Aid flow (current US$) in High income: nonOECD in 2005 to that in 2012?
Make the answer very short. 1.17. What is the ratio of the Aid flow (current US$) of World in 2005 to that in 2012?
Provide a short and direct response. 0.39. What is the ratio of the Aid flow (current US$) in Kyrgyz Republic in 2005 to that in 2012?
Give a very brief answer. 0.42. What is the ratio of the Aid flow (current US$) in Senegal in 2005 to that in 2012?
Make the answer very short. 0.01. What is the ratio of the Aid flow (current US$) of High income: nonOECD in 2006 to that in 2007?
Make the answer very short. 0.65. What is the ratio of the Aid flow (current US$) in World in 2006 to that in 2007?
Offer a terse response. 0.77. What is the ratio of the Aid flow (current US$) in Kyrgyz Republic in 2006 to that in 2007?
Your answer should be very brief. 4.07. What is the ratio of the Aid flow (current US$) in Senegal in 2006 to that in 2007?
Offer a very short reply. 0.35. What is the ratio of the Aid flow (current US$) of World in 2006 to that in 2008?
Make the answer very short. 0.7. What is the ratio of the Aid flow (current US$) in Kyrgyz Republic in 2006 to that in 2008?
Your answer should be compact. 0.86. What is the ratio of the Aid flow (current US$) of Senegal in 2006 to that in 2008?
Offer a very short reply. 0.08. What is the ratio of the Aid flow (current US$) of World in 2006 to that in 2009?
Ensure brevity in your answer.  0.65. What is the ratio of the Aid flow (current US$) of Kyrgyz Republic in 2006 to that in 2009?
Offer a very short reply. 0.85. What is the ratio of the Aid flow (current US$) of Senegal in 2006 to that in 2009?
Keep it short and to the point. 0.14. What is the ratio of the Aid flow (current US$) of World in 2006 to that in 2010?
Ensure brevity in your answer.  0.42. What is the ratio of the Aid flow (current US$) of Kyrgyz Republic in 2006 to that in 2010?
Provide a succinct answer. 0.33. What is the ratio of the Aid flow (current US$) in Senegal in 2006 to that in 2010?
Keep it short and to the point. 0.06. What is the ratio of the Aid flow (current US$) of World in 2006 to that in 2011?
Offer a very short reply. 0.38. What is the ratio of the Aid flow (current US$) in Kyrgyz Republic in 2006 to that in 2011?
Offer a very short reply. 0.5. What is the ratio of the Aid flow (current US$) of Senegal in 2006 to that in 2011?
Your answer should be compact. 0.1. What is the ratio of the Aid flow (current US$) of High income: nonOECD in 2006 to that in 2012?
Your answer should be very brief. 0.71. What is the ratio of the Aid flow (current US$) in World in 2006 to that in 2012?
Offer a terse response. 0.32. What is the ratio of the Aid flow (current US$) of Kyrgyz Republic in 2006 to that in 2012?
Give a very brief answer. 0.61. What is the ratio of the Aid flow (current US$) in Senegal in 2006 to that in 2012?
Keep it short and to the point. 0.03. What is the ratio of the Aid flow (current US$) of World in 2007 to that in 2008?
Your answer should be very brief. 0.91. What is the ratio of the Aid flow (current US$) of Kyrgyz Republic in 2007 to that in 2008?
Make the answer very short. 0.21. What is the ratio of the Aid flow (current US$) of Senegal in 2007 to that in 2008?
Make the answer very short. 0.24. What is the ratio of the Aid flow (current US$) of World in 2007 to that in 2009?
Ensure brevity in your answer.  0.84. What is the ratio of the Aid flow (current US$) in Kyrgyz Republic in 2007 to that in 2009?
Offer a terse response. 0.21. What is the ratio of the Aid flow (current US$) of Senegal in 2007 to that in 2009?
Keep it short and to the point. 0.41. What is the ratio of the Aid flow (current US$) in World in 2007 to that in 2010?
Give a very brief answer. 0.54. What is the ratio of the Aid flow (current US$) in Kyrgyz Republic in 2007 to that in 2010?
Offer a terse response. 0.08. What is the ratio of the Aid flow (current US$) of Senegal in 2007 to that in 2010?
Ensure brevity in your answer.  0.16. What is the ratio of the Aid flow (current US$) of High income: nonOECD in 2007 to that in 2011?
Your answer should be compact. 1.28. What is the ratio of the Aid flow (current US$) in World in 2007 to that in 2011?
Make the answer very short. 0.5. What is the ratio of the Aid flow (current US$) of Kyrgyz Republic in 2007 to that in 2011?
Ensure brevity in your answer.  0.12. What is the ratio of the Aid flow (current US$) of Senegal in 2007 to that in 2011?
Your response must be concise. 0.28. What is the ratio of the Aid flow (current US$) in High income: nonOECD in 2007 to that in 2012?
Keep it short and to the point. 1.1. What is the ratio of the Aid flow (current US$) in World in 2007 to that in 2012?
Offer a very short reply. 0.41. What is the ratio of the Aid flow (current US$) in Senegal in 2007 to that in 2012?
Keep it short and to the point. 0.08. What is the ratio of the Aid flow (current US$) of World in 2008 to that in 2009?
Give a very brief answer. 0.93. What is the ratio of the Aid flow (current US$) of Kyrgyz Republic in 2008 to that in 2009?
Your answer should be compact. 0.99. What is the ratio of the Aid flow (current US$) of Senegal in 2008 to that in 2009?
Your answer should be very brief. 1.73. What is the ratio of the Aid flow (current US$) in World in 2008 to that in 2010?
Make the answer very short. 0.6. What is the ratio of the Aid flow (current US$) of Kyrgyz Republic in 2008 to that in 2010?
Make the answer very short. 0.39. What is the ratio of the Aid flow (current US$) in Senegal in 2008 to that in 2010?
Your answer should be very brief. 0.69. What is the ratio of the Aid flow (current US$) in World in 2008 to that in 2011?
Ensure brevity in your answer.  0.54. What is the ratio of the Aid flow (current US$) of Kyrgyz Republic in 2008 to that in 2011?
Ensure brevity in your answer.  0.59. What is the ratio of the Aid flow (current US$) in Senegal in 2008 to that in 2011?
Your answer should be compact. 1.18. What is the ratio of the Aid flow (current US$) in World in 2008 to that in 2012?
Your answer should be very brief. 0.46. What is the ratio of the Aid flow (current US$) of Kyrgyz Republic in 2008 to that in 2012?
Provide a succinct answer. 0.71. What is the ratio of the Aid flow (current US$) of Senegal in 2008 to that in 2012?
Your answer should be very brief. 0.32. What is the ratio of the Aid flow (current US$) of World in 2009 to that in 2010?
Provide a succinct answer. 0.65. What is the ratio of the Aid flow (current US$) of Kyrgyz Republic in 2009 to that in 2010?
Make the answer very short. 0.39. What is the ratio of the Aid flow (current US$) of Senegal in 2009 to that in 2010?
Your answer should be compact. 0.4. What is the ratio of the Aid flow (current US$) in World in 2009 to that in 2011?
Make the answer very short. 0.59. What is the ratio of the Aid flow (current US$) in Kyrgyz Republic in 2009 to that in 2011?
Provide a succinct answer. 0.59. What is the ratio of the Aid flow (current US$) in Senegal in 2009 to that in 2011?
Provide a succinct answer. 0.68. What is the ratio of the Aid flow (current US$) of World in 2009 to that in 2012?
Provide a short and direct response. 0.49. What is the ratio of the Aid flow (current US$) in Kyrgyz Republic in 2009 to that in 2012?
Your answer should be very brief. 0.72. What is the ratio of the Aid flow (current US$) of Senegal in 2009 to that in 2012?
Keep it short and to the point. 0.19. What is the ratio of the Aid flow (current US$) in World in 2010 to that in 2011?
Your answer should be very brief. 0.91. What is the ratio of the Aid flow (current US$) of Kyrgyz Republic in 2010 to that in 2011?
Provide a succinct answer. 1.51. What is the ratio of the Aid flow (current US$) in Senegal in 2010 to that in 2011?
Your response must be concise. 1.7. What is the ratio of the Aid flow (current US$) of World in 2010 to that in 2012?
Keep it short and to the point. 0.76. What is the ratio of the Aid flow (current US$) in Kyrgyz Republic in 2010 to that in 2012?
Your answer should be compact. 1.83. What is the ratio of the Aid flow (current US$) of Senegal in 2010 to that in 2012?
Ensure brevity in your answer.  0.47. What is the ratio of the Aid flow (current US$) of World in 2011 to that in 2012?
Provide a succinct answer. 0.84. What is the ratio of the Aid flow (current US$) in Kyrgyz Republic in 2011 to that in 2012?
Offer a terse response. 1.21. What is the ratio of the Aid flow (current US$) in Senegal in 2011 to that in 2012?
Keep it short and to the point. 0.27. What is the difference between the highest and the second highest Aid flow (current US$) of World?
Provide a short and direct response. 1.94e+08. What is the difference between the highest and the second highest Aid flow (current US$) in Kyrgyz Republic?
Your answer should be very brief. 6.20e+05. What is the difference between the highest and the second highest Aid flow (current US$) in Senegal?
Keep it short and to the point. 1.68e+07. What is the difference between the highest and the lowest Aid flow (current US$) of High income: nonOECD?
Ensure brevity in your answer.  8.20e+05. What is the difference between the highest and the lowest Aid flow (current US$) in World?
Keep it short and to the point. 8.07e+08. What is the difference between the highest and the lowest Aid flow (current US$) in Kyrgyz Republic?
Provide a succinct answer. 1.68e+06. What is the difference between the highest and the lowest Aid flow (current US$) of Senegal?
Offer a very short reply. 3.14e+07. 